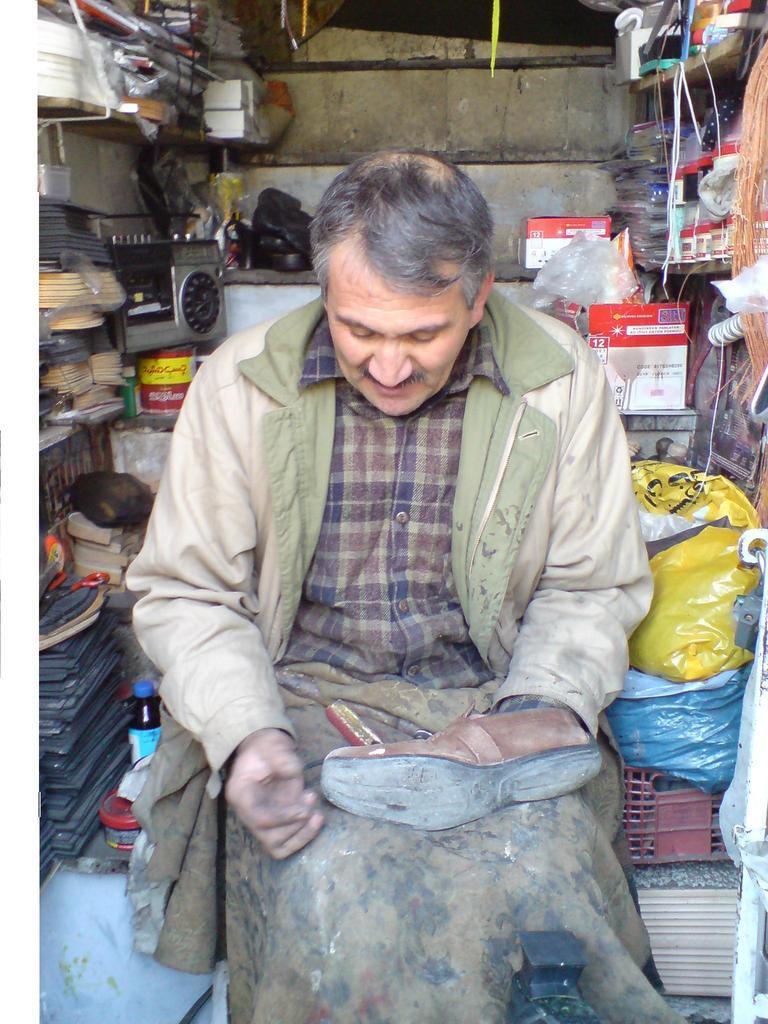Please provide a concise description of this image. In the center of the picture we can see a person holding shoe, he is sitting in a small store. On the left there are shoe sole, tape recorder and other objects. On the right there are covers, boxes, threads and other objects. In the background it is well. 